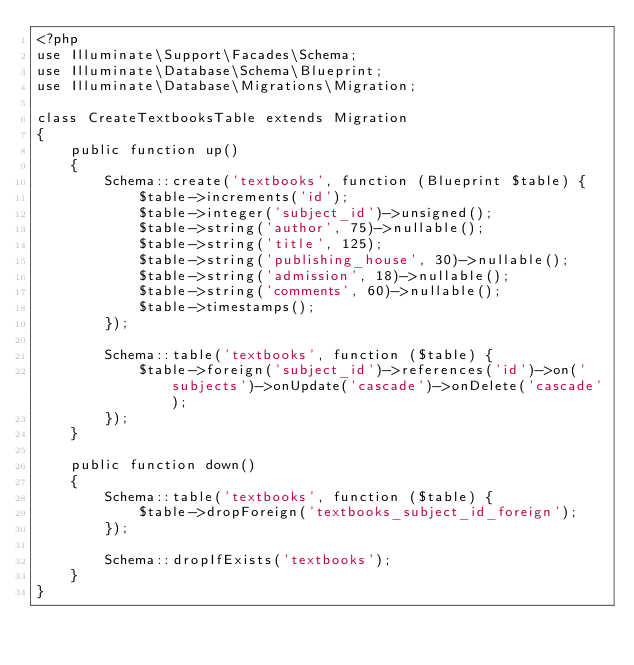<code> <loc_0><loc_0><loc_500><loc_500><_PHP_><?php
use Illuminate\Support\Facades\Schema;
use Illuminate\Database\Schema\Blueprint;
use Illuminate\Database\Migrations\Migration;

class CreateTextbooksTable extends Migration
{
    public function up()
    {
        Schema::create('textbooks', function (Blueprint $table) {
            $table->increments('id');
            $table->integer('subject_id')->unsigned();
            $table->string('author', 75)->nullable();
            $table->string('title', 125);
            $table->string('publishing_house', 30)->nullable();
            $table->string('admission', 18)->nullable();
            $table->string('comments', 60)->nullable();
            $table->timestamps();
        });

        Schema::table('textbooks', function ($table) {
            $table->foreign('subject_id')->references('id')->on('subjects')->onUpdate('cascade')->onDelete('cascade');
        });
    }

    public function down()
    {
        Schema::table('textbooks', function ($table) {
            $table->dropForeign('textbooks_subject_id_foreign');
        });

        Schema::dropIfExists('textbooks');
    }
}</code> 